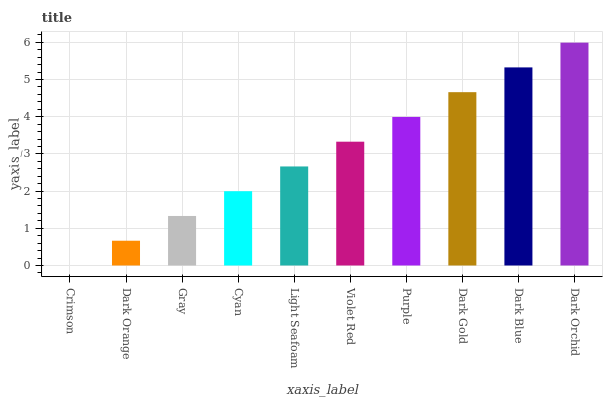Is Dark Orange the minimum?
Answer yes or no. No. Is Dark Orange the maximum?
Answer yes or no. No. Is Dark Orange greater than Crimson?
Answer yes or no. Yes. Is Crimson less than Dark Orange?
Answer yes or no. Yes. Is Crimson greater than Dark Orange?
Answer yes or no. No. Is Dark Orange less than Crimson?
Answer yes or no. No. Is Violet Red the high median?
Answer yes or no. Yes. Is Light Seafoam the low median?
Answer yes or no. Yes. Is Dark Orange the high median?
Answer yes or no. No. Is Crimson the low median?
Answer yes or no. No. 